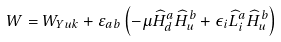Convert formula to latex. <formula><loc_0><loc_0><loc_500><loc_500>W = W _ { Y u k } + \varepsilon _ { a b } \left ( - \mu \widehat { H } _ { d } ^ { a } \widehat { H } _ { u } ^ { b } + \epsilon _ { i } \widehat { L } _ { i } ^ { a } \widehat { H } _ { u } ^ { b } \right )</formula> 